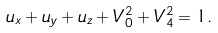<formula> <loc_0><loc_0><loc_500><loc_500>u _ { x } + u _ { y } + u _ { z } + V _ { 0 } ^ { 2 } + V _ { 4 } ^ { 2 } = 1 .</formula> 